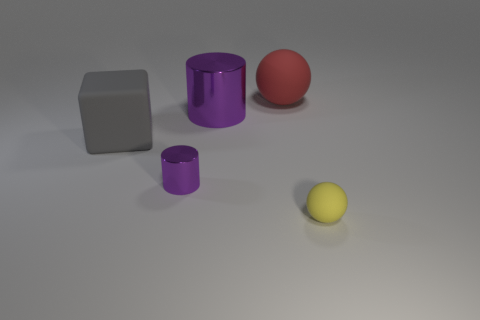Add 4 red matte balls. How many objects exist? 9 Subtract all cylinders. How many objects are left? 3 Add 3 small cylinders. How many small cylinders are left? 4 Add 1 big red objects. How many big red objects exist? 2 Subtract 1 yellow balls. How many objects are left? 4 Subtract all large blocks. Subtract all gray matte cubes. How many objects are left? 3 